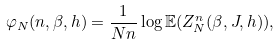Convert formula to latex. <formula><loc_0><loc_0><loc_500><loc_500>\varphi _ { N } ( n , \beta , h ) = \frac { 1 } { N n } \log { \mathbb { E } ( Z ^ { n } _ { N } ( \beta , J , h ) ) } ,</formula> 